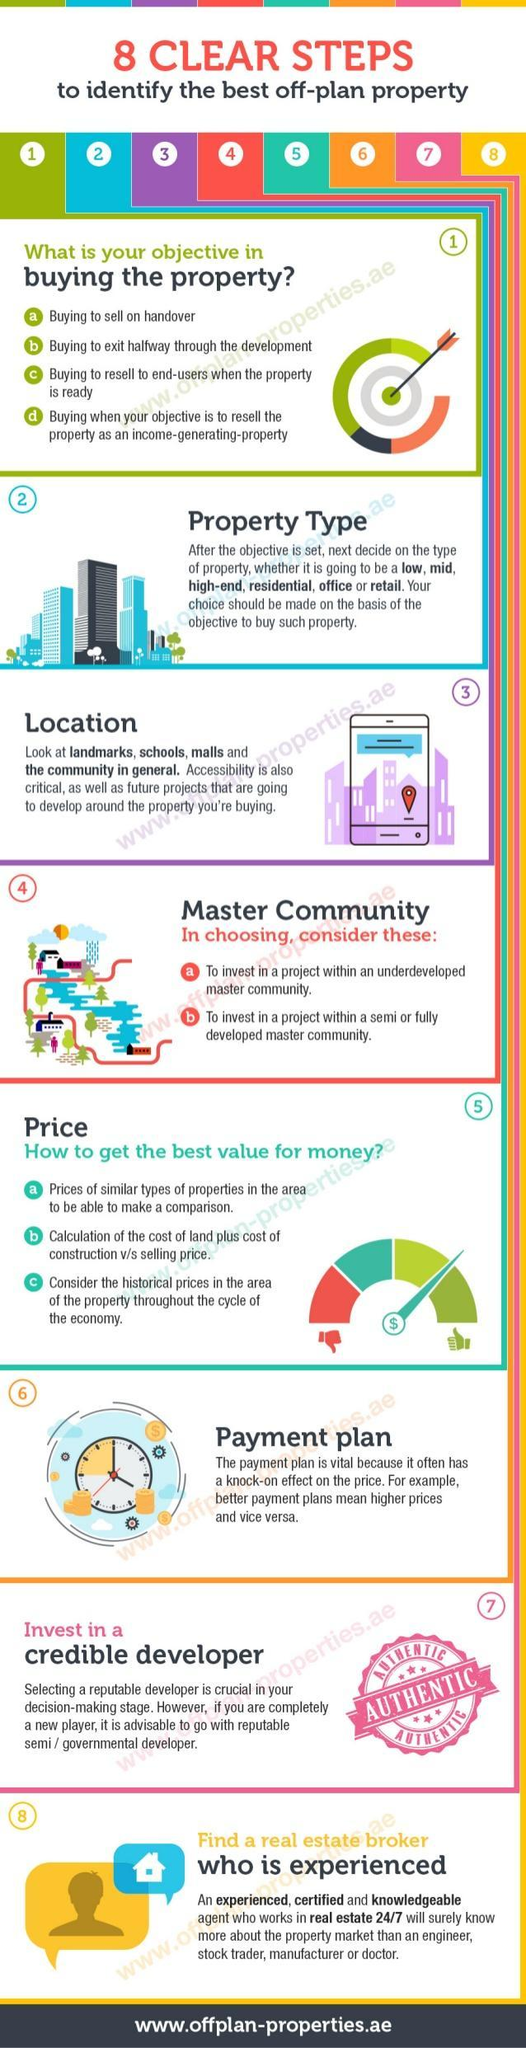How many factors have been listed in choosing master community?
Answer the question with a short phrase. 2 How many objectives in buying the property have been listed in the infographic? 4 